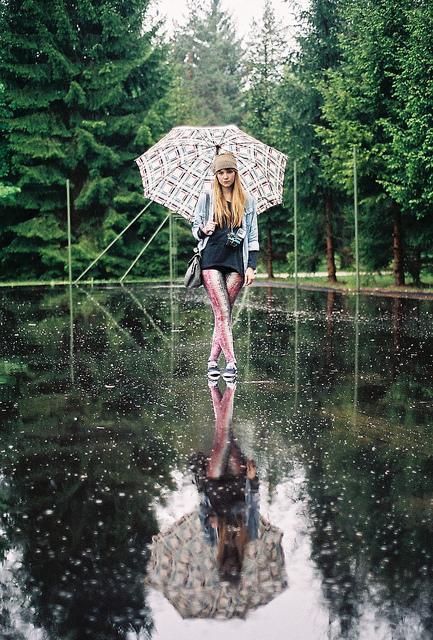How many people are using backpacks or bags?
Give a very brief answer. 0. 